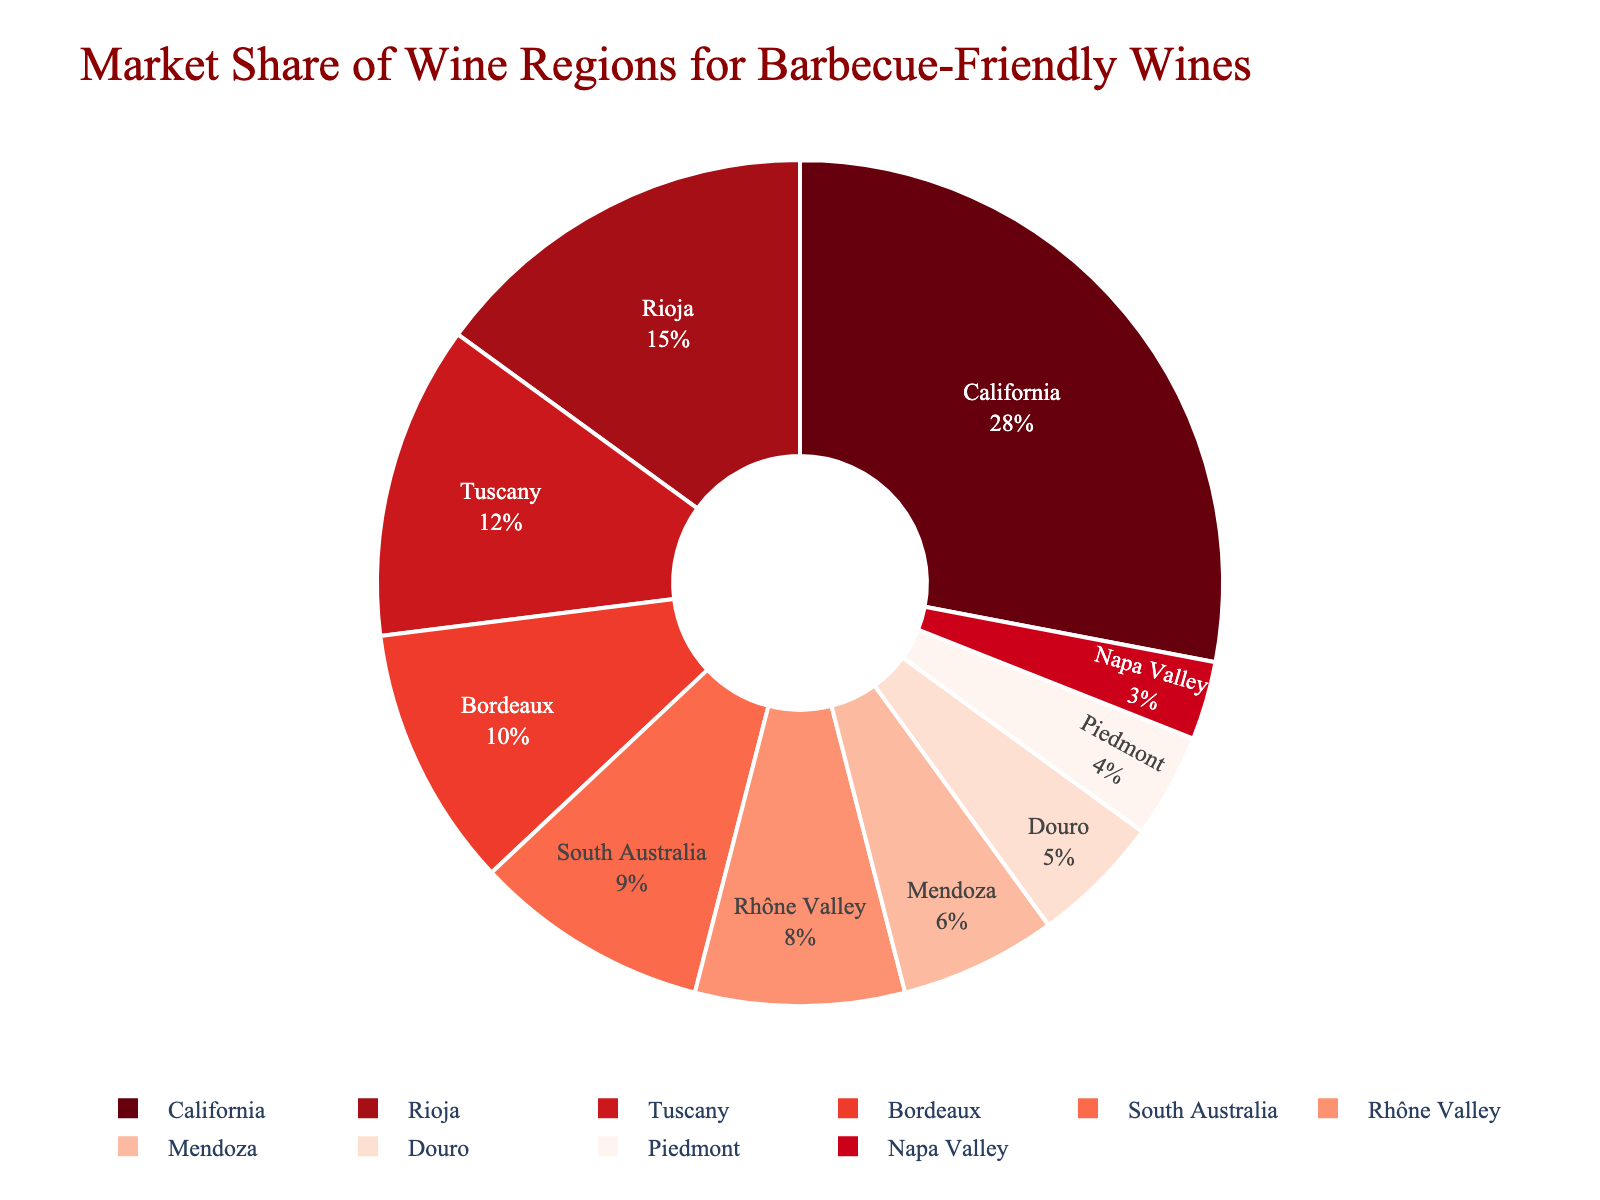what's the market share of the top three wine regions? To find the market share of the top three wine regions, add the market shares of California (28%), Rioja (15%), and Tuscany (12%). The sum is 28 + 15 + 12 = 55.
Answer: 55 which wine region has a lower market share: Mendoza or Douro? Compare the market shares of Mendoza (6%) and Douro (5%). 6% (Mendoza) is greater than 5% (Douro), so Douro has a lower market share.
Answer: Douro does South Australia have more market share than the Rhône Valley and Napa Valley combined? Compare South Australia's market share (9%) with the combined market share of Rhône Valley (8%) and Napa Valley (3%). The combined market share for Rhône Valley and Napa Valley is 8 + 3 = 11%. 9% is less than 11%, so South Australia does not have more market share.
Answer: No which region occupies the smallest segment of the pie chart and what is its market share? Observe the smallest segment of the pie chart, which corresponds to Napa Valley. Napa Valley has a market share of 3%.
Answer: Napa Valley, 3% is the market share of Bordeaux twice as high as that of Piedmont? Compare Bordeaux’s market share (10%) with twice the market share of Piedmont (4%). Twice the market share of Piedmont is 4 * 2 = 8%. 10% is not twice as high as 8%.
Answer: No how much higher is California's market share compared to South Australia's? Subtract South Australia's market share (9%) from California's market share (28%). 28% - 9% = 19%.
Answer: 19% what is the total market share of European wine regions shown? Add the market shares of Rioja (15%), Tuscany (12%), Bordeaux (10%), Rhône Valley (8%), Douro (5%), and Piedmont (4%). The sum is 15 + 12 + 10 + 8 + 5 + 4 = 54%.
Answer: 54 which wine regions have a market share greater than 10%? Identify the regions with market shares greater than 10%. California (28%), Rioja (15%), and Tuscany (12%) have market shares greater than 10%.
Answer: California, Rioja, and Tuscany 